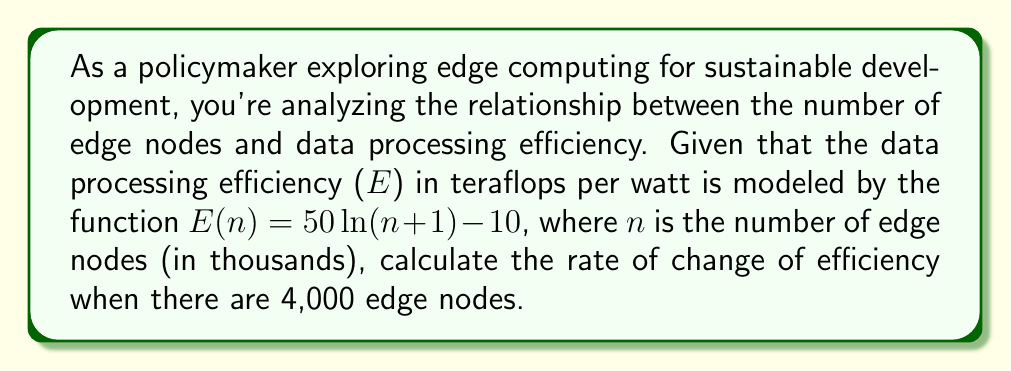Can you solve this math problem? To solve this problem, we need to find the derivative of the given function and then evaluate it at the specified point. Let's break it down step-by-step:

1) The given function is:
   $E(n) = 50\ln(n+1) - 10$

2) To find the rate of change, we need to calculate the derivative $E'(n)$:
   $E'(n) = \frac{d}{dn}[50\ln(n+1) - 10]$

3) Using the chain rule and the fact that the derivative of $\ln(x)$ is $\frac{1}{x}$, we get:
   $E'(n) = 50 \cdot \frac{1}{n+1} \cdot \frac{d}{dn}(n+1) - 0$
   $E'(n) = 50 \cdot \frac{1}{n+1} \cdot 1$
   $E'(n) = \frac{50}{n+1}$

4) Now, we need to evaluate this at n = 4 (since n is in thousands, and we're given 4,000 nodes):
   $E'(4) = \frac{50}{4+1} = \frac{50}{5} = 10$

Therefore, when there are 4,000 edge nodes, the rate of change of efficiency is 10 teraflops per watt per thousand nodes.
Answer: $10$ teraflops per watt per thousand nodes 